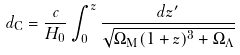Convert formula to latex. <formula><loc_0><loc_0><loc_500><loc_500>d _ { \mathrm C } = \frac { c } { H _ { 0 } } \int _ { 0 } ^ { z } \frac { d z ^ { \prime } } { \sqrt { \Omega _ { \mathrm M } ( 1 + z ) ^ { 3 } + \Omega _ { \Lambda } } }</formula> 